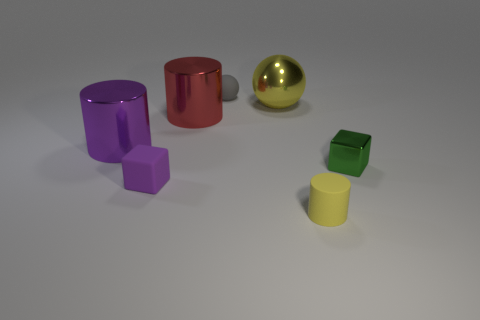There is a block that is the same material as the red object; what size is it?
Your answer should be compact. Small. What is the color of the rubber block?
Your answer should be very brief. Purple. How many rubber objects have the same color as the large ball?
Offer a terse response. 1. There is a gray sphere that is the same size as the purple cube; what material is it?
Your response must be concise. Rubber. Are there any small blocks that are left of the yellow matte thing on the right side of the tiny gray sphere?
Offer a terse response. Yes. What number of other objects are the same color as the shiny cube?
Provide a succinct answer. 0. The purple metallic object has what size?
Your response must be concise. Large. Is there a large yellow metallic ball?
Your answer should be very brief. Yes. Are there more small balls in front of the small metal cube than big balls to the right of the small ball?
Make the answer very short. No. There is a thing that is both behind the big red thing and in front of the tiny gray matte thing; what material is it?
Provide a succinct answer. Metal. 